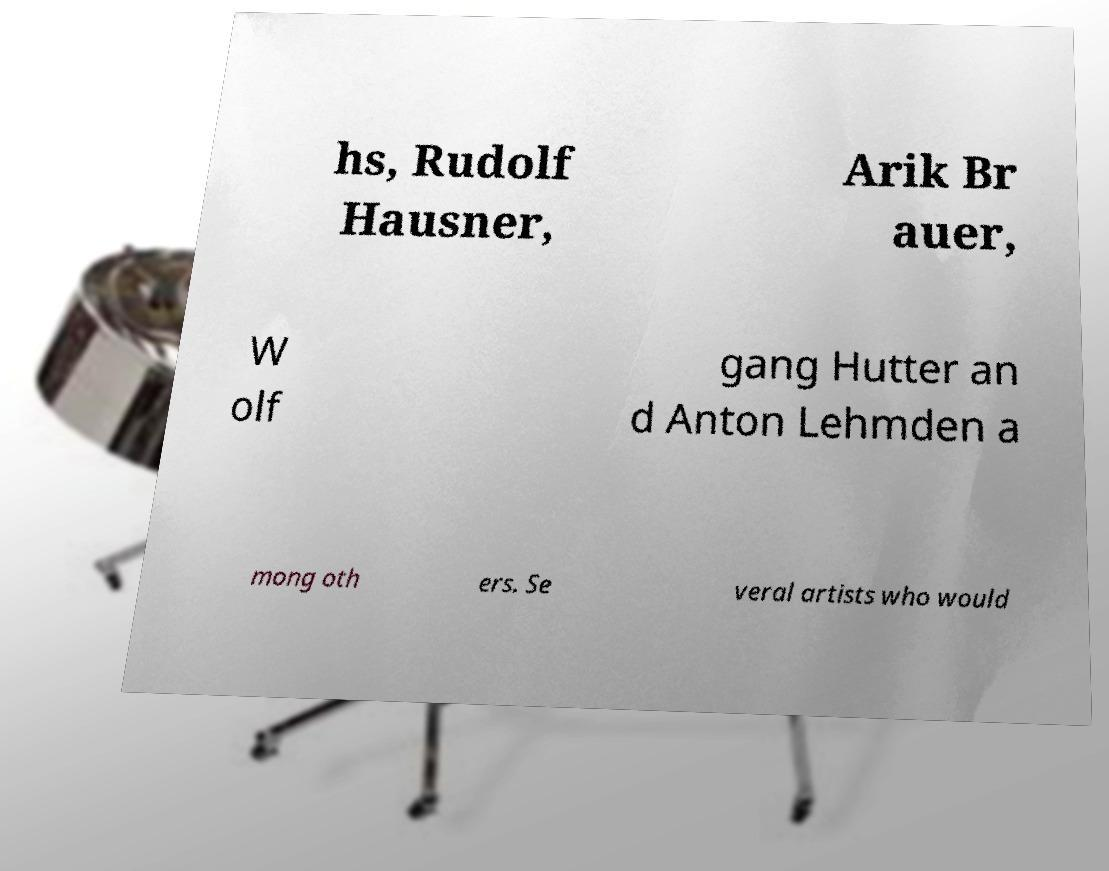Please read and relay the text visible in this image. What does it say? hs, Rudolf Hausner, Arik Br auer, W olf gang Hutter an d Anton Lehmden a mong oth ers. Se veral artists who would 